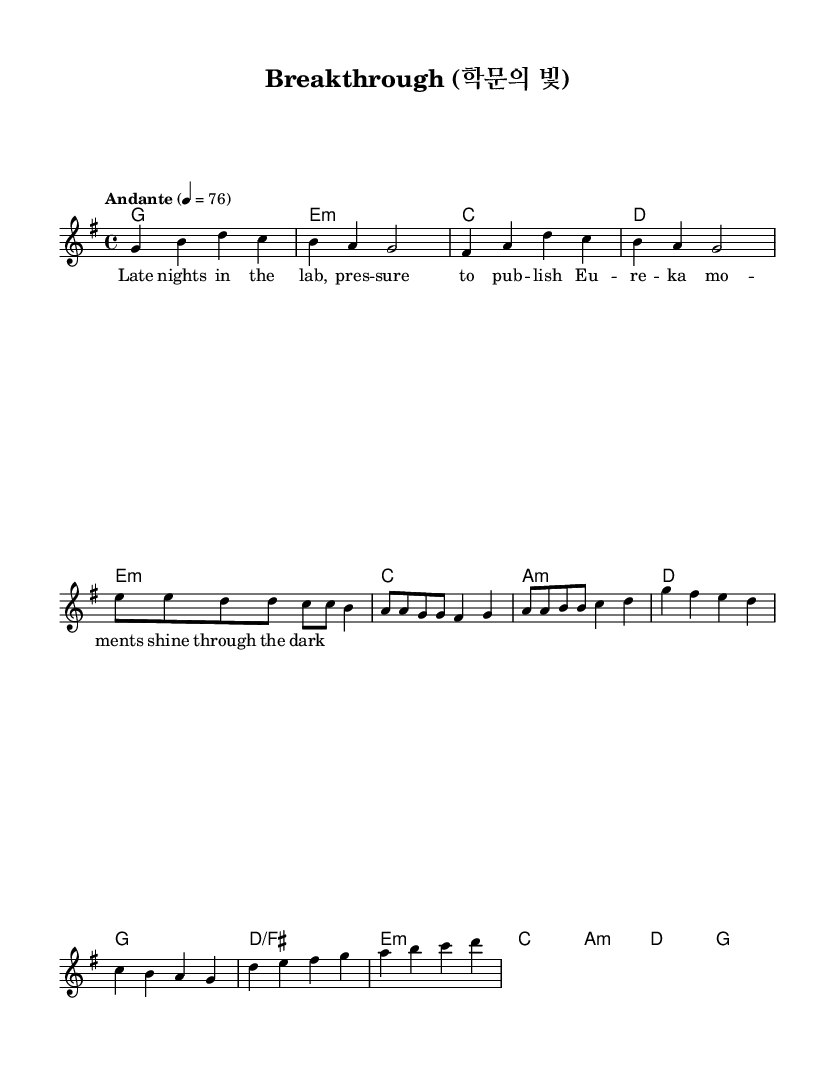What is the key signature of this music? The key signature is G major, which has one sharp (F#). This can be identified by looking for the sharp sign in the key signature section of the sheet music.
Answer: G major What is the time signature of this piece? The time signature is 4/4, which is indicated at the beginning of the sheet music. This means there are four beats in each measure, and the quarter note gets one beat.
Answer: 4/4 What is the tempo marking for this piece? The tempo marking is "Andante," with a metronome marking of 76 beats per minute. This is listed at the beginning of the score.
Answer: Andante How many measures are in the verse section? The verse section consists of 4 measures, which can be counted by identifying each group of notes separated by vertical lines (bar lines) in the melody section.
Answer: 4 What kind of musical form is exhibited in this piece? The piece follows a verse-pre-chorus-chorus structure, which is common in K-Pop ballads, highlighted by the arrangement of sections in the score.
Answer: Verse-pre-chorus-chorus Which chord is played during the pre-chorus? The chords during the pre-chorus are E minor, C major, A minor, and D major, as indicated in the harmony section, showcasing a progression typical for building emotional intensity.
Answer: E minor, C major, A minor, D major 